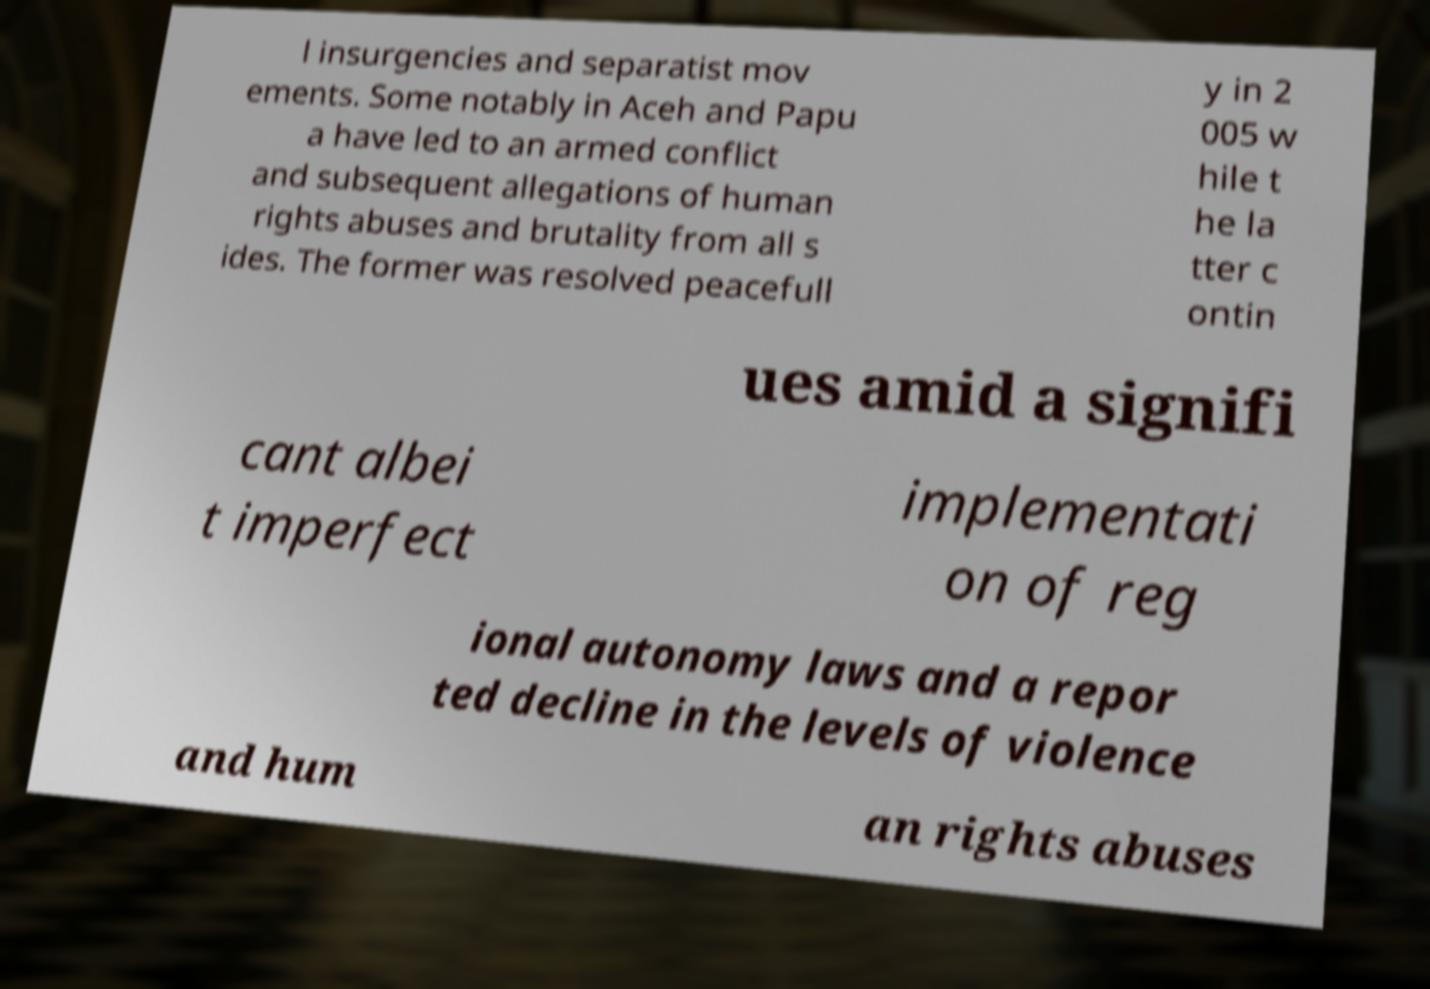Could you extract and type out the text from this image? l insurgencies and separatist mov ements. Some notably in Aceh and Papu a have led to an armed conflict and subsequent allegations of human rights abuses and brutality from all s ides. The former was resolved peacefull y in 2 005 w hile t he la tter c ontin ues amid a signifi cant albei t imperfect implementati on of reg ional autonomy laws and a repor ted decline in the levels of violence and hum an rights abuses 